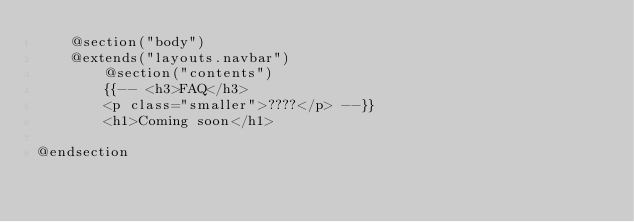Convert code to text. <code><loc_0><loc_0><loc_500><loc_500><_PHP_>    @section("body")
    @extends("layouts.navbar")
        @section("contents")
        {{-- <h3>FAQ</h3>
        <p class="smaller">????</p> --}}
        <h1>Coming soon</h1>
        
@endsection</code> 